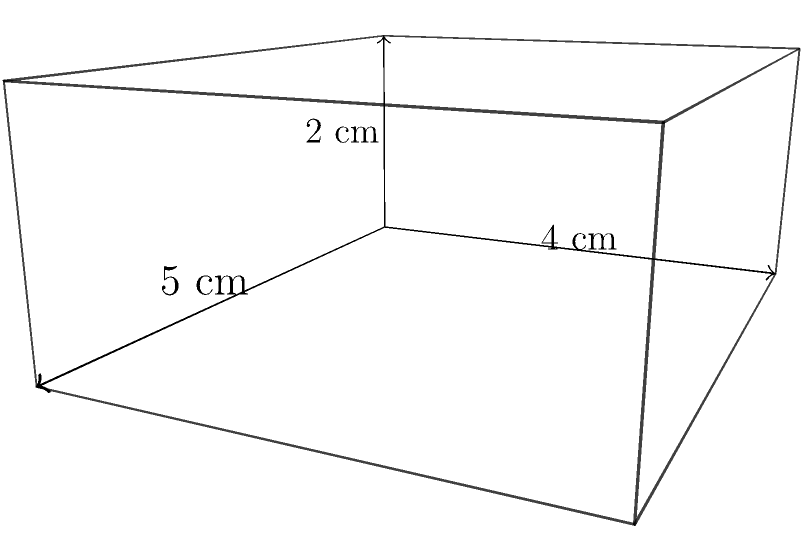As a restaurant owner offering discounts to moviegoers, you want to design a new pizza box for takeout orders. The box is modeled as a rectangular prism with dimensions 5 cm x 4 cm x 2 cm. What is the volume of this pizza box in cubic centimeters? To find the volume of a rectangular prism, we need to multiply its length, width, and height.

Let's identify the dimensions:
Length (l) = 5 cm
Width (w) = 4 cm
Height (h) = 2 cm

The formula for the volume of a rectangular prism is:
$$V = l \times w \times h$$

Substituting the values:
$$V = 5 \text{ cm} \times 4 \text{ cm} \times 2 \text{ cm}$$

Calculating:
$$V = 40 \text{ cm}^3$$

Therefore, the volume of the pizza box is 40 cubic centimeters.
Answer: 40 cm³ 